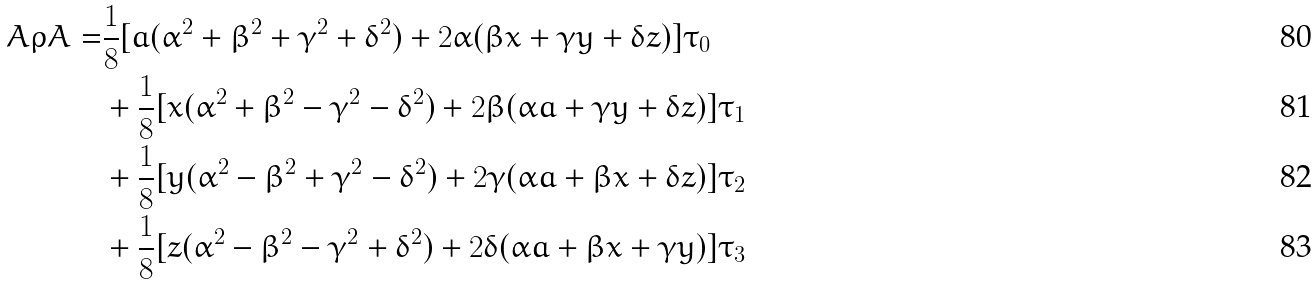<formula> <loc_0><loc_0><loc_500><loc_500>A \rho A = & \frac { 1 } { 8 } [ a ( \alpha ^ { 2 } + \beta ^ { 2 } + \gamma ^ { 2 } + \delta ^ { 2 } ) + 2 \alpha ( \beta x + \gamma y + \delta z ) ] \tau _ { 0 } \\ & + \frac { 1 } { 8 } [ x ( \alpha ^ { 2 } + \beta ^ { 2 } - \gamma ^ { 2 } - \delta ^ { 2 } ) + 2 \beta ( \alpha a + \gamma y + \delta z ) ] \tau _ { 1 } \\ & + \frac { 1 } { 8 } [ y ( \alpha ^ { 2 } - \beta ^ { 2 } + \gamma ^ { 2 } - \delta ^ { 2 } ) + 2 \gamma ( \alpha a + \beta x + \delta z ) ] \tau _ { 2 } \\ & + \frac { 1 } { 8 } [ z ( \alpha ^ { 2 } - \beta ^ { 2 } - \gamma ^ { 2 } + \delta ^ { 2 } ) + 2 \delta ( \alpha a + \beta x + \gamma y ) ] \tau _ { 3 }</formula> 